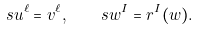Convert formula to latex. <formula><loc_0><loc_0><loc_500><loc_500>s u ^ { \ell } = v ^ { \ell } , \quad s w ^ { I } = r ^ { I } ( w ) .</formula> 